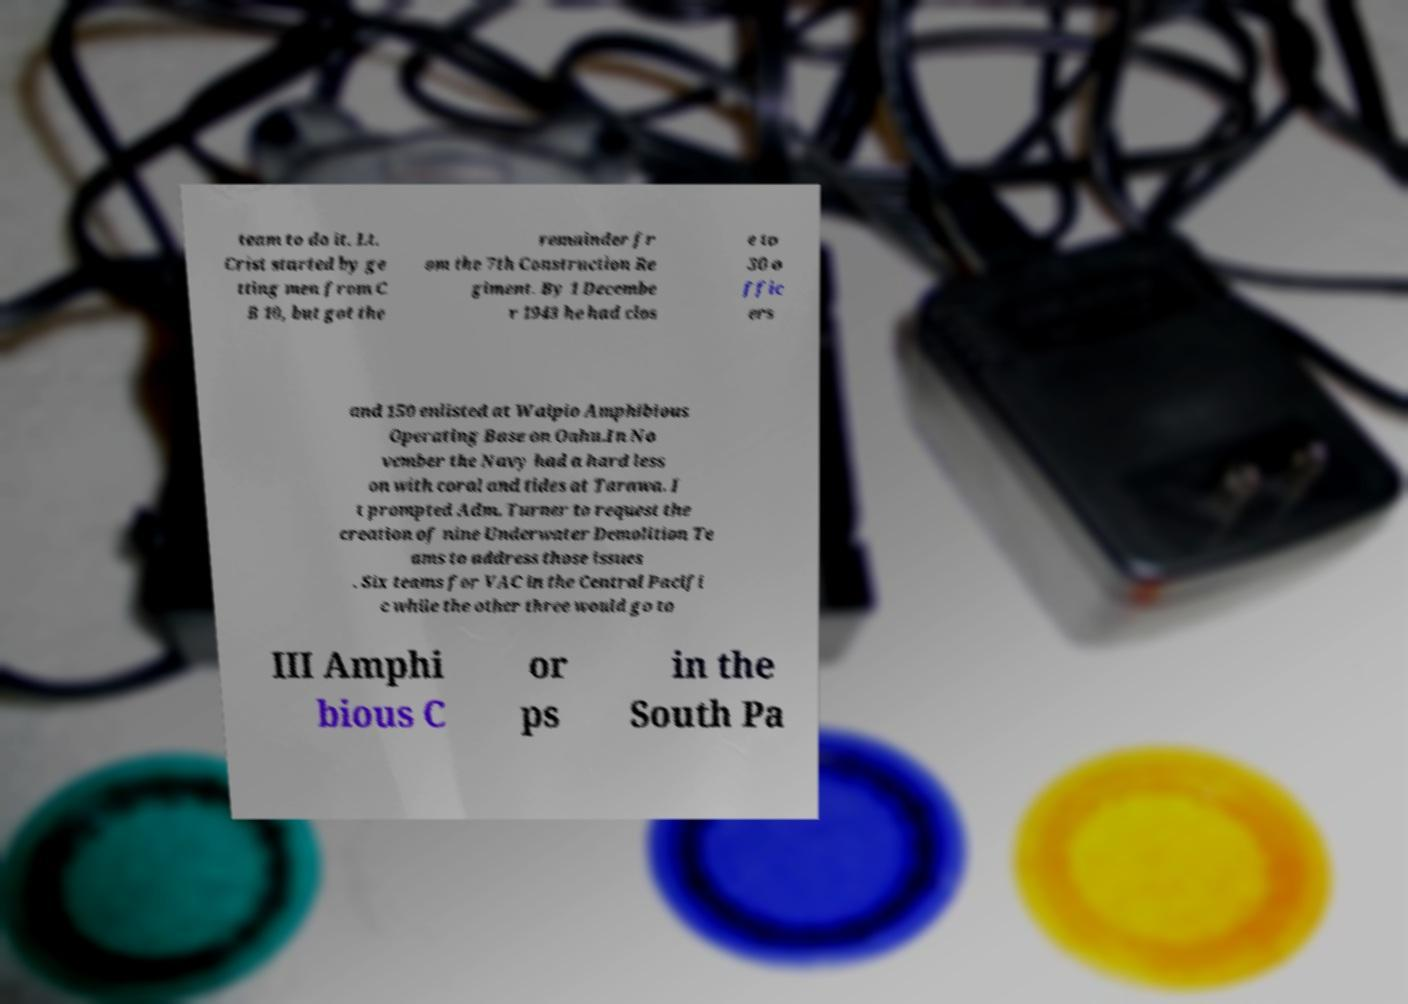Please identify and transcribe the text found in this image. team to do it. Lt. Crist started by ge tting men from C B 10, but got the remainder fr om the 7th Construction Re giment. By 1 Decembe r 1943 he had clos e to 30 o ffic ers and 150 enlisted at Waipio Amphibious Operating Base on Oahu.In No vember the Navy had a hard less on with coral and tides at Tarawa. I t prompted Adm. Turner to request the creation of nine Underwater Demolition Te ams to address those issues . Six teams for VAC in the Central Pacifi c while the other three would go to III Amphi bious C or ps in the South Pa 